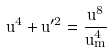Convert formula to latex. <formula><loc_0><loc_0><loc_500><loc_500>u ^ { 4 } + u ^ { \prime 2 } = \frac { u ^ { 8 } } { u _ { m } ^ { 4 } }</formula> 